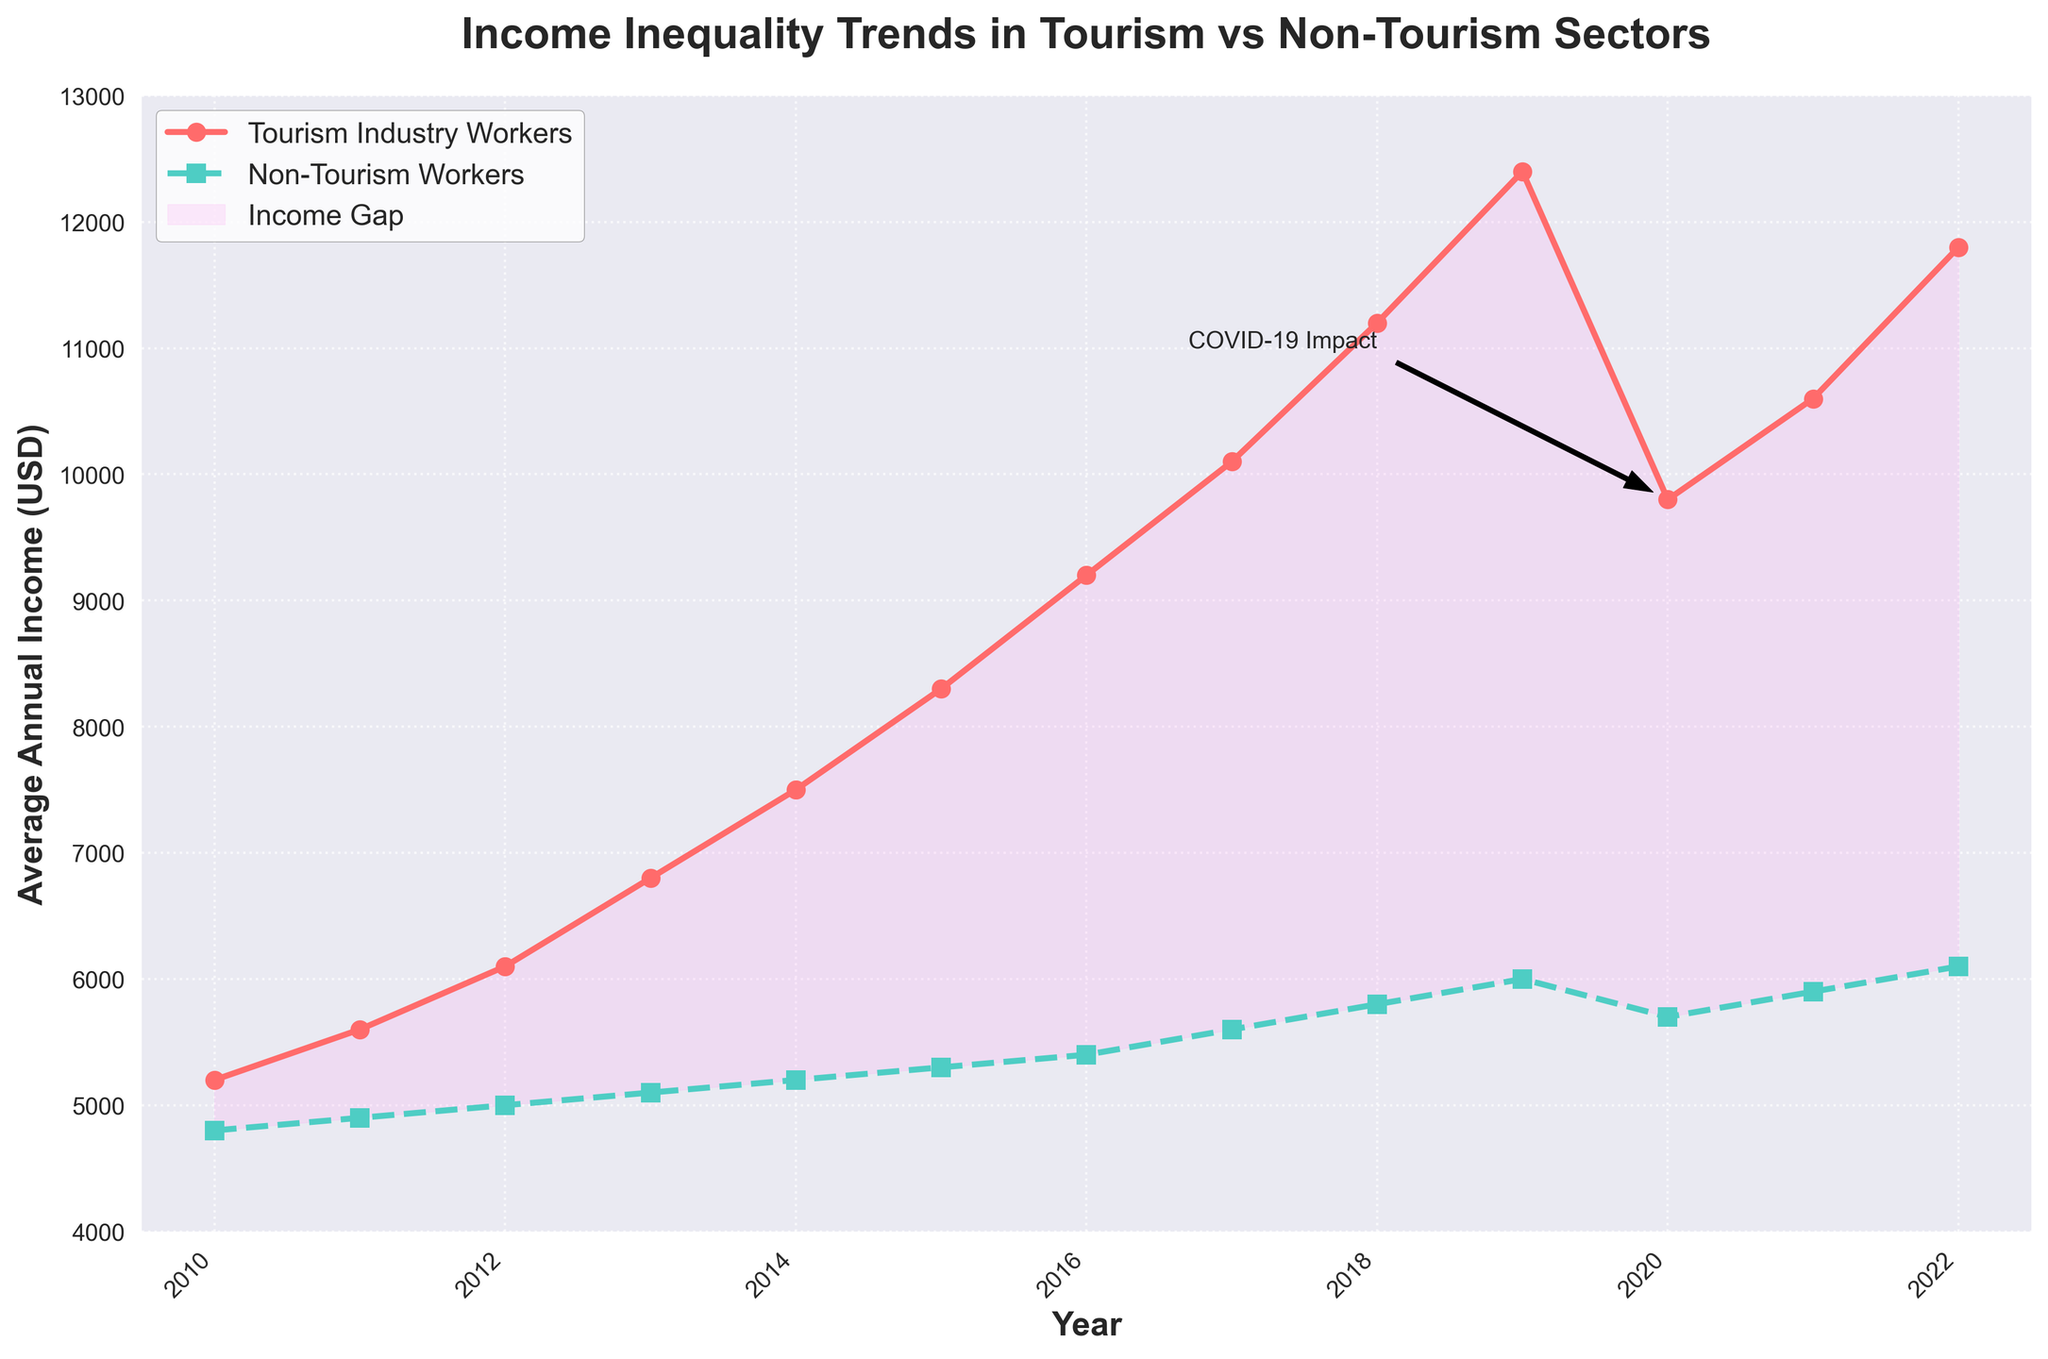How did the income disparity between tourism and non-tourism workers change from 2010 to 2022? To find the income disparity, we subtract the average annual income of non-tourism workers from that of tourism workers for each year. In 2010, the disparity is 5200 - 4800 = 400 USD. In 2022, it is 11800 - 6100 = 5700 USD, indicating an increase in disparity over this period.
Answer: Disparity increased from 400 USD to 5700 USD Which year showed the largest income gap between tourism and non-tourism workers? By examining the space between the two lines, 2019 has the largest income gap, with tourism workers earning 12400 USD and non-tourism workers earning 6000 USD. The gap is 12400 - 6000 = 6400 USD.
Answer: 2019 In which year do we see a notable decline in the income of tourism industry workers? By observing the trend in the line for tourism income, there is a significant drop from 12400 USD in 2019 to 9800 USD in 2020.
Answer: 2020 How did the incomes of both tourism and non-tourism workers change in 2020, the year noted with COVID-19 impact? In 2020, tourism workers' income dropped from 12400 USD in 2019 to 9800 USD, and non-tourism workers' income dropped from 6000 USD in 2019 to 5700 USD. The tourism sector saw a sharper decline.
Answer: Tourism: -2600 USD, Non-Tourism: -300 USD What is the average income of tourism workers over the years 2010 to 2022? To find the average, sum all the annual incomes of tourism workers from 2010 to 2022 and divide by the number of years: (5200 + 5600 + 6100 + 6800 + 7500 + 8300 + 9200 + 10100 + 11200 + 12400 + 9800 + 10600 + 11800) / 13 = 8661.54 USD.
Answer: 8661.54 USD Which group had a more consistent growth in income over the years, tourism or non-tourism workers? By observing the lines, non-tourism workers' income grew more consistently, maintaining a steady upward trend, while tourism workers' income shows more fluctuations, especially the drop in 2020.
Answer: Non-tourism workers Looking at the income of tourism workers, during which two consecutive years did their income grow the most? The steepest slope in the tourism income line is between 2018 and 2019, where income increased from 11200 USD to 12400 USD, a growth of 1200 USD.
Answer: 2018-2019 How does the gap between the incomes of tourism and non-tourism workers change after 2020 compared to before it? Before 2020, the gap was increasing steadily. In 2020, the gap reduced due to the drop in tourism income, but after 2020, the gap began to increase again from 10600 - 5900 = 4700 USD in 2021 to 11800 - 6100 = 5700 USD in 2022.
Answer: The gap decreased in 2020 but increased again after Which group’s average income doubles first from the year 2010? The income of tourism workers exceeds double (5200 * 2 = 10400 USD) in 2019 (12400 USD), while non-tourism workers exceed double (4800 * 2 = 9600 USD) only beyond the given years (still below even in 2022).
Answer: Tourism workers in 2019 How often do incomes of non-tourism workers rise without any decline? By observing the line for non-tourism workers, we see a consistent rise every year without any decline.
Answer: Every year 